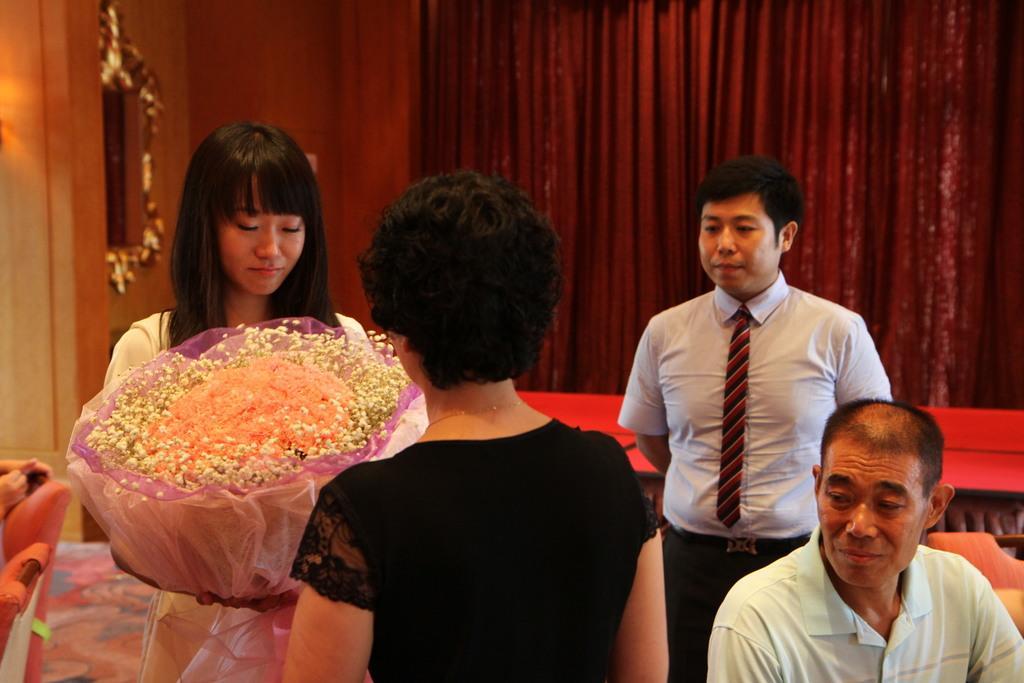Can you describe this image briefly? In this image there are people. In the front there is a woman holding a flower bouquet in her hand. In the background there is a red colour curtain. On the left side there are chairs. 